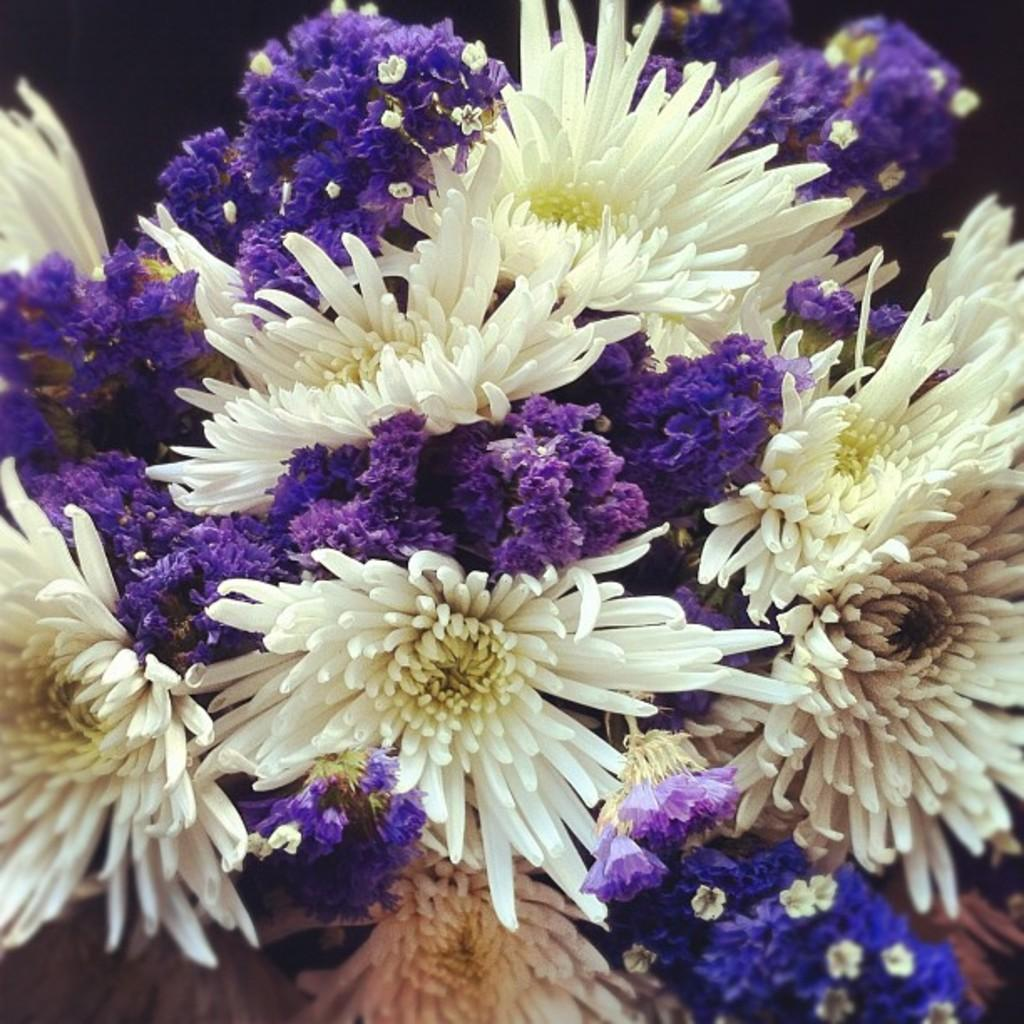What type of flower is featured in the image? There is a white and purple flower in the image. Can you describe the color scheme of the flower? The flower has white and purple colors. What can be observed in the top left corner of the image? The top left corner of the image appears to be dark. What type of locket is hanging from the stem of the flower in the image? There is no locket present in the image; it only features a white and purple flower. 